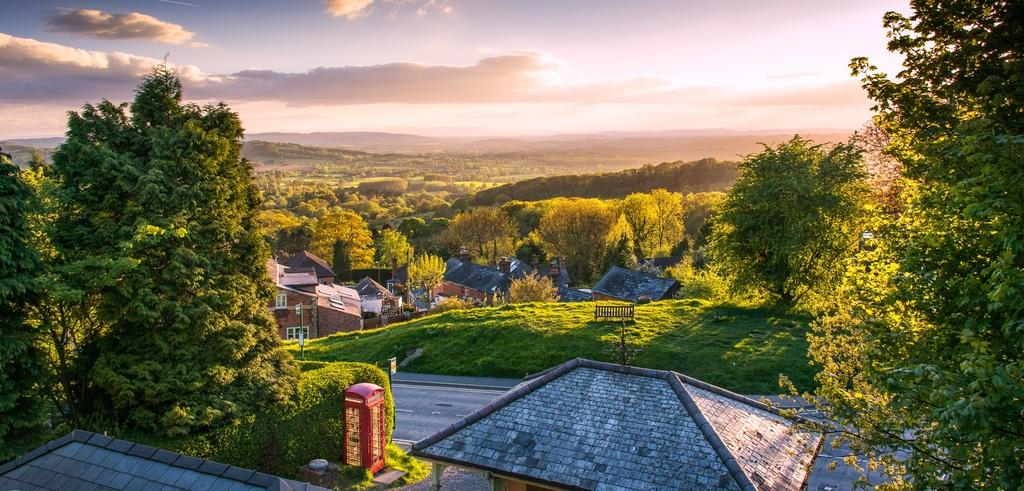What type of natural environment is depicted in the image? There are a lot of trees in the image, suggesting a forest or wooded area. Are there any man-made structures visible in the image? Yes, there are houses in the image. How is the image described in terms of time of day? The image is described as a beautiful view in the morning. How many feet are visible in the image? There are no feet visible in the image. What type of vessel is being used to transport people in the image? There is no vessel present in the image. 